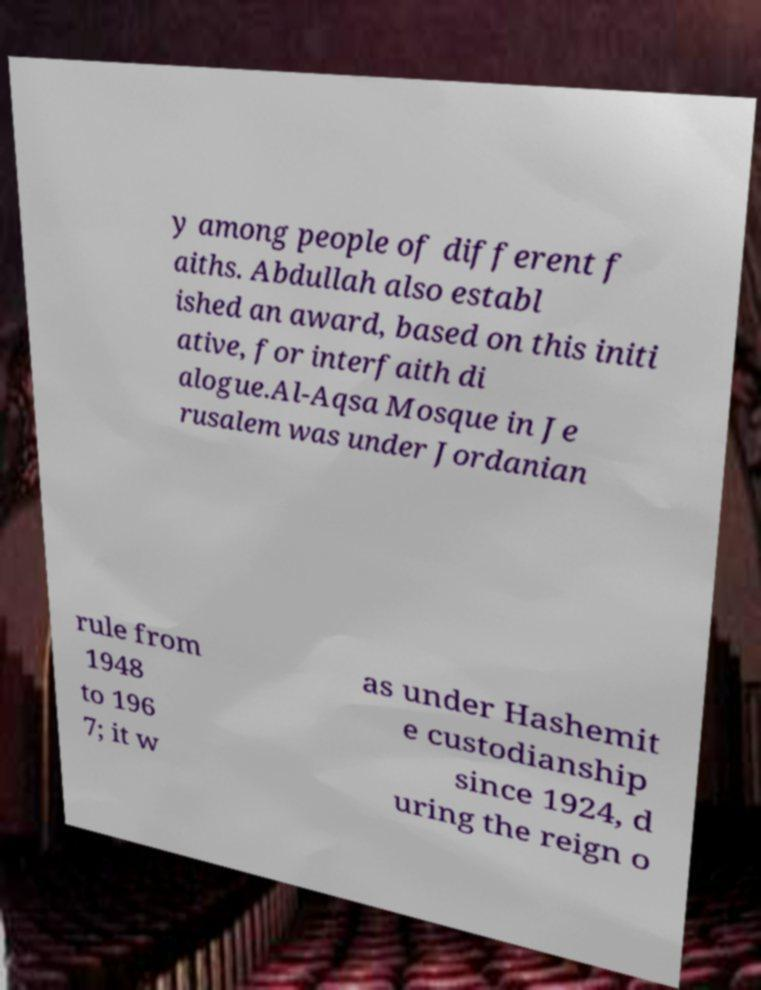There's text embedded in this image that I need extracted. Can you transcribe it verbatim? y among people of different f aiths. Abdullah also establ ished an award, based on this initi ative, for interfaith di alogue.Al-Aqsa Mosque in Je rusalem was under Jordanian rule from 1948 to 196 7; it w as under Hashemit e custodianship since 1924, d uring the reign o 